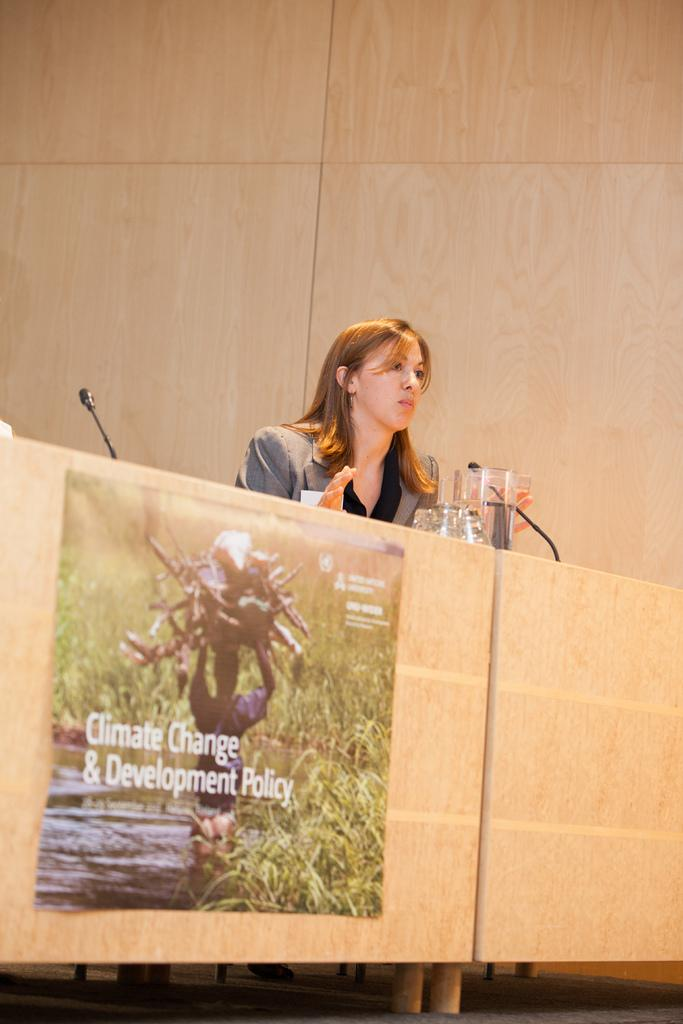What objects are on the tables in the foreground of the picture? There are glasses and a jar on the table. What other object can be seen on the table? There is a microphone on the table. Who is in the center of the picture? There is a woman in the center of the picture. What is visible in the background of the picture? There is a well in the background of the picture. How many snakes are slithering around the woman in the picture? There are no snakes present in the image. What type of paper is the cub using to draw in the picture? There is no cub or paper present in the image. 